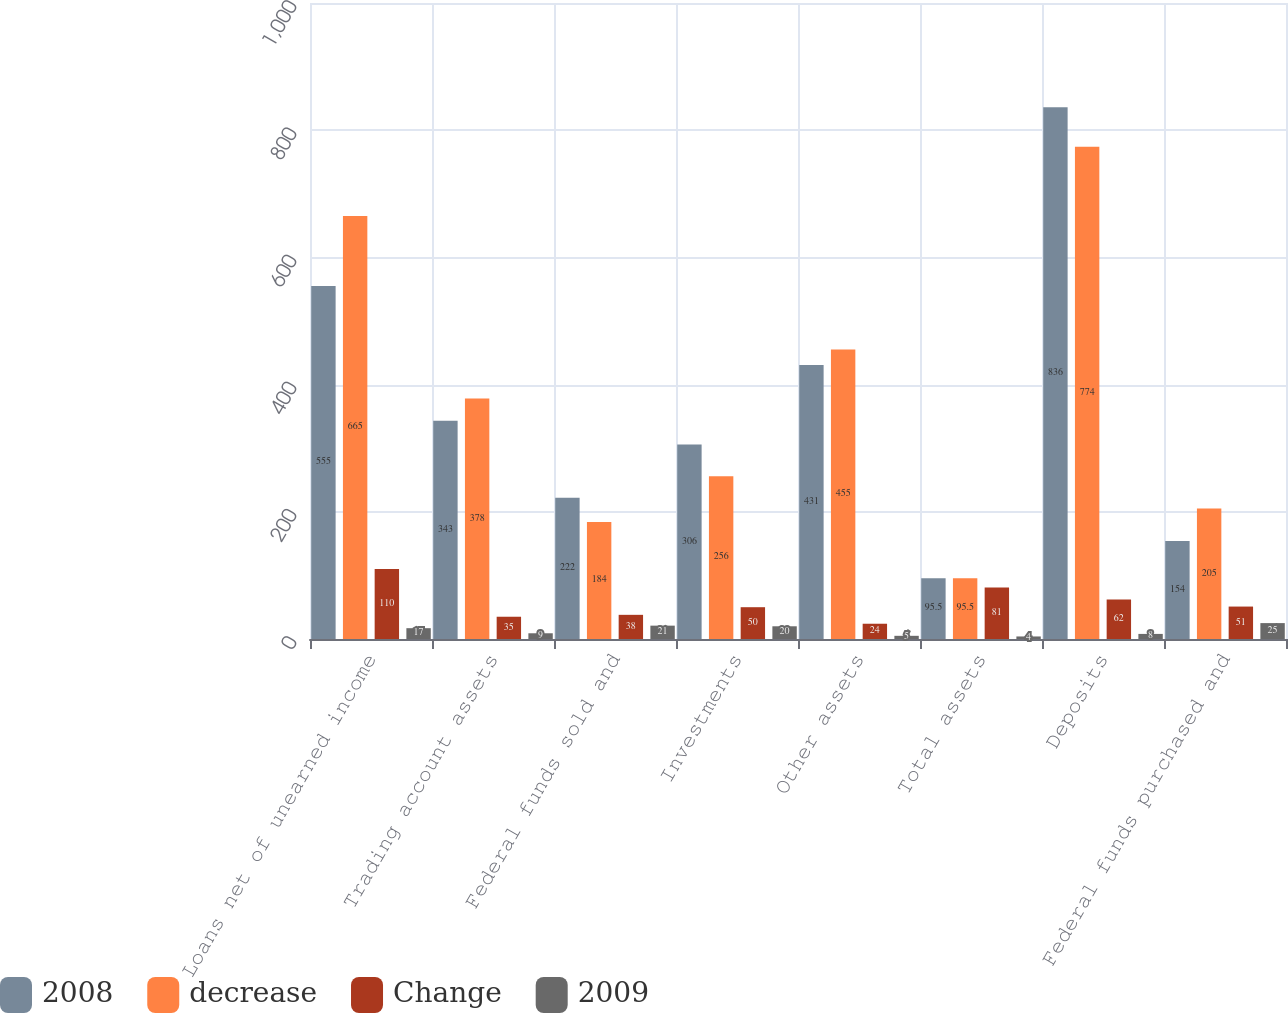Convert chart. <chart><loc_0><loc_0><loc_500><loc_500><stacked_bar_chart><ecel><fcel>Loans net of unearned income<fcel>Trading account assets<fcel>Federal funds sold and<fcel>Investments<fcel>Other assets<fcel>Total assets<fcel>Deposits<fcel>Federal funds purchased and<nl><fcel>2008<fcel>555<fcel>343<fcel>222<fcel>306<fcel>431<fcel>95.5<fcel>836<fcel>154<nl><fcel>decrease<fcel>665<fcel>378<fcel>184<fcel>256<fcel>455<fcel>95.5<fcel>774<fcel>205<nl><fcel>Change<fcel>110<fcel>35<fcel>38<fcel>50<fcel>24<fcel>81<fcel>62<fcel>51<nl><fcel>2009<fcel>17<fcel>9<fcel>21<fcel>20<fcel>5<fcel>4<fcel>8<fcel>25<nl></chart> 